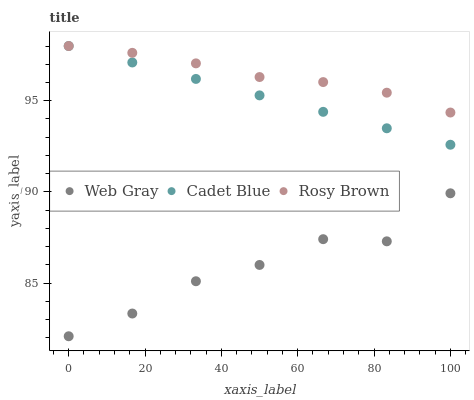Does Web Gray have the minimum area under the curve?
Answer yes or no. Yes. Does Rosy Brown have the maximum area under the curve?
Answer yes or no. Yes. Does Rosy Brown have the minimum area under the curve?
Answer yes or no. No. Does Web Gray have the maximum area under the curve?
Answer yes or no. No. Is Cadet Blue the smoothest?
Answer yes or no. Yes. Is Web Gray the roughest?
Answer yes or no. Yes. Is Rosy Brown the smoothest?
Answer yes or no. No. Is Rosy Brown the roughest?
Answer yes or no. No. Does Web Gray have the lowest value?
Answer yes or no. Yes. Does Rosy Brown have the lowest value?
Answer yes or no. No. Does Rosy Brown have the highest value?
Answer yes or no. Yes. Does Web Gray have the highest value?
Answer yes or no. No. Is Web Gray less than Rosy Brown?
Answer yes or no. Yes. Is Cadet Blue greater than Web Gray?
Answer yes or no. Yes. Does Cadet Blue intersect Rosy Brown?
Answer yes or no. Yes. Is Cadet Blue less than Rosy Brown?
Answer yes or no. No. Is Cadet Blue greater than Rosy Brown?
Answer yes or no. No. Does Web Gray intersect Rosy Brown?
Answer yes or no. No. 